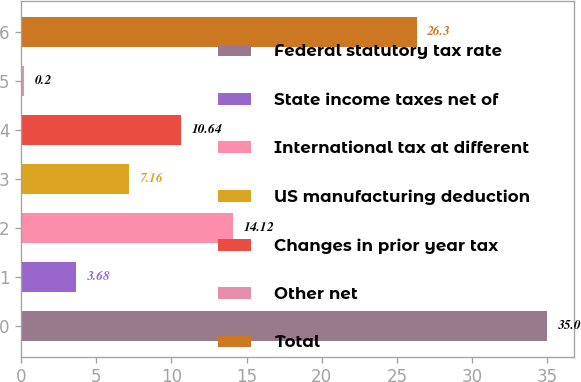Convert chart to OTSL. <chart><loc_0><loc_0><loc_500><loc_500><bar_chart><fcel>Federal statutory tax rate<fcel>State income taxes net of<fcel>International tax at different<fcel>US manufacturing deduction<fcel>Changes in prior year tax<fcel>Other net<fcel>Total<nl><fcel>35<fcel>3.68<fcel>14.12<fcel>7.16<fcel>10.64<fcel>0.2<fcel>26.3<nl></chart> 